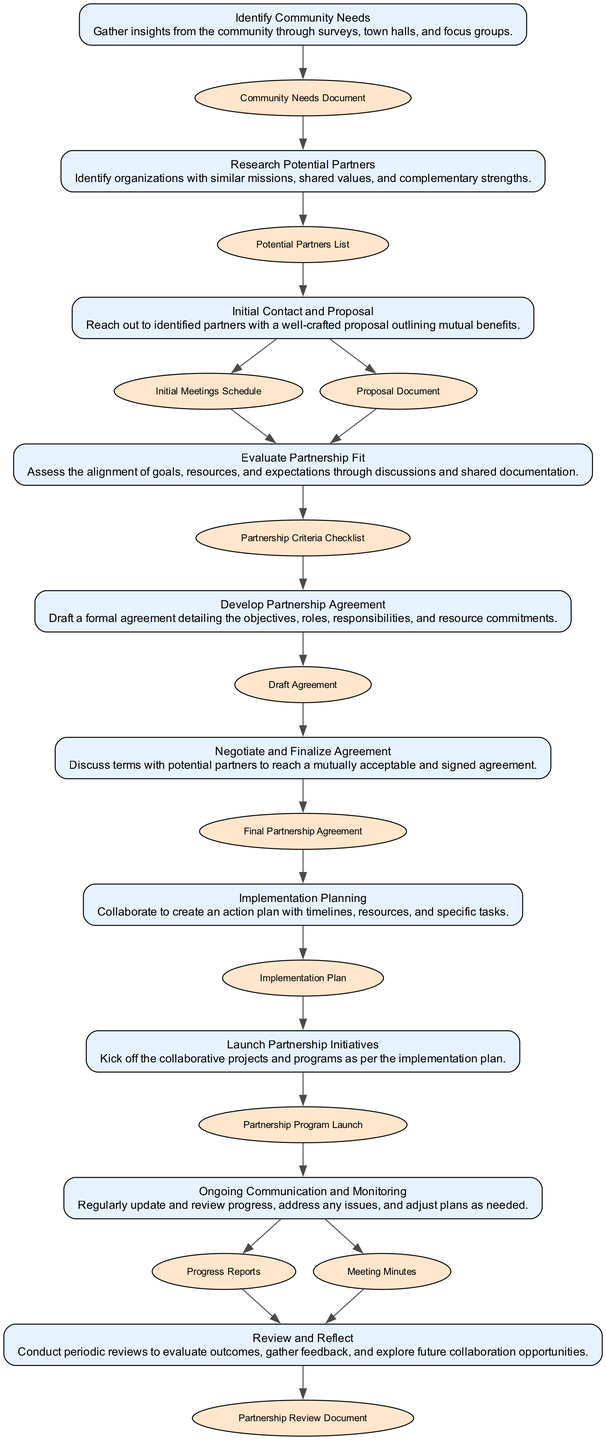What is the first step in the process? The first step is "Identify Community Needs," which is directly mentioned at the top of the diagram as the starting point.
Answer: Identify Community Needs What document is produced after identifying community needs? The output from the "Identify Community Needs" step is the "Community Needs Document," which is listed as the output of that step.
Answer: Community Needs Document How many steps are there in total? By counting the elements in the diagram, there are ten distinct steps outlined in the partnership development process.
Answer: Ten Which step comes after researching potential partners? Following "Research Potential Partners," the next step shown in the diagram is "Initial Contact and Proposal," indicating a progression based on the outputs of the prior step.
Answer: Initial Contact and Proposal What is the final output of the partnership development process? The last output generated in the process is the "Partnership Review Document," which culminates the series of steps aimed at evaluating and reflecting on the partnership outcomes.
Answer: Partnership Review Document What inputs are needed to develop the partnership agreement? The input required for the "Develop Partnership Agreement" step is the "Partnership Criteria Checklist," which results from the previous evaluation step.
Answer: Partnership Criteria Checklist What is the mutual goal during the negotiation phase? The mutual goal during the "Negotiate and Finalize Agreement" phase is to reach a "Final Partnership Agreement," signifying that both parties have discussed and finalized the terms.
Answer: Final Partnership Agreement How do the steps "Launch Partnership Initiatives" and "Ongoing Communication and Monitoring" connect? "Launch Partnership Initiatives" provides the output "Partnership Program Launch," which then serves as an input into "Ongoing Communication and Monitoring," indicating that monitoring actions are dependent on the launch phase.
Answer: Partnership Program Launch What is the purpose of the "Review and Reflect" step? The purpose of the "Review and Reflect" step is to evaluate outcomes and explore future collaboration opportunities, as indicated in its description at the bottom of the diagram.
Answer: Evaluate outcomes, explore future collaboration opportunities 